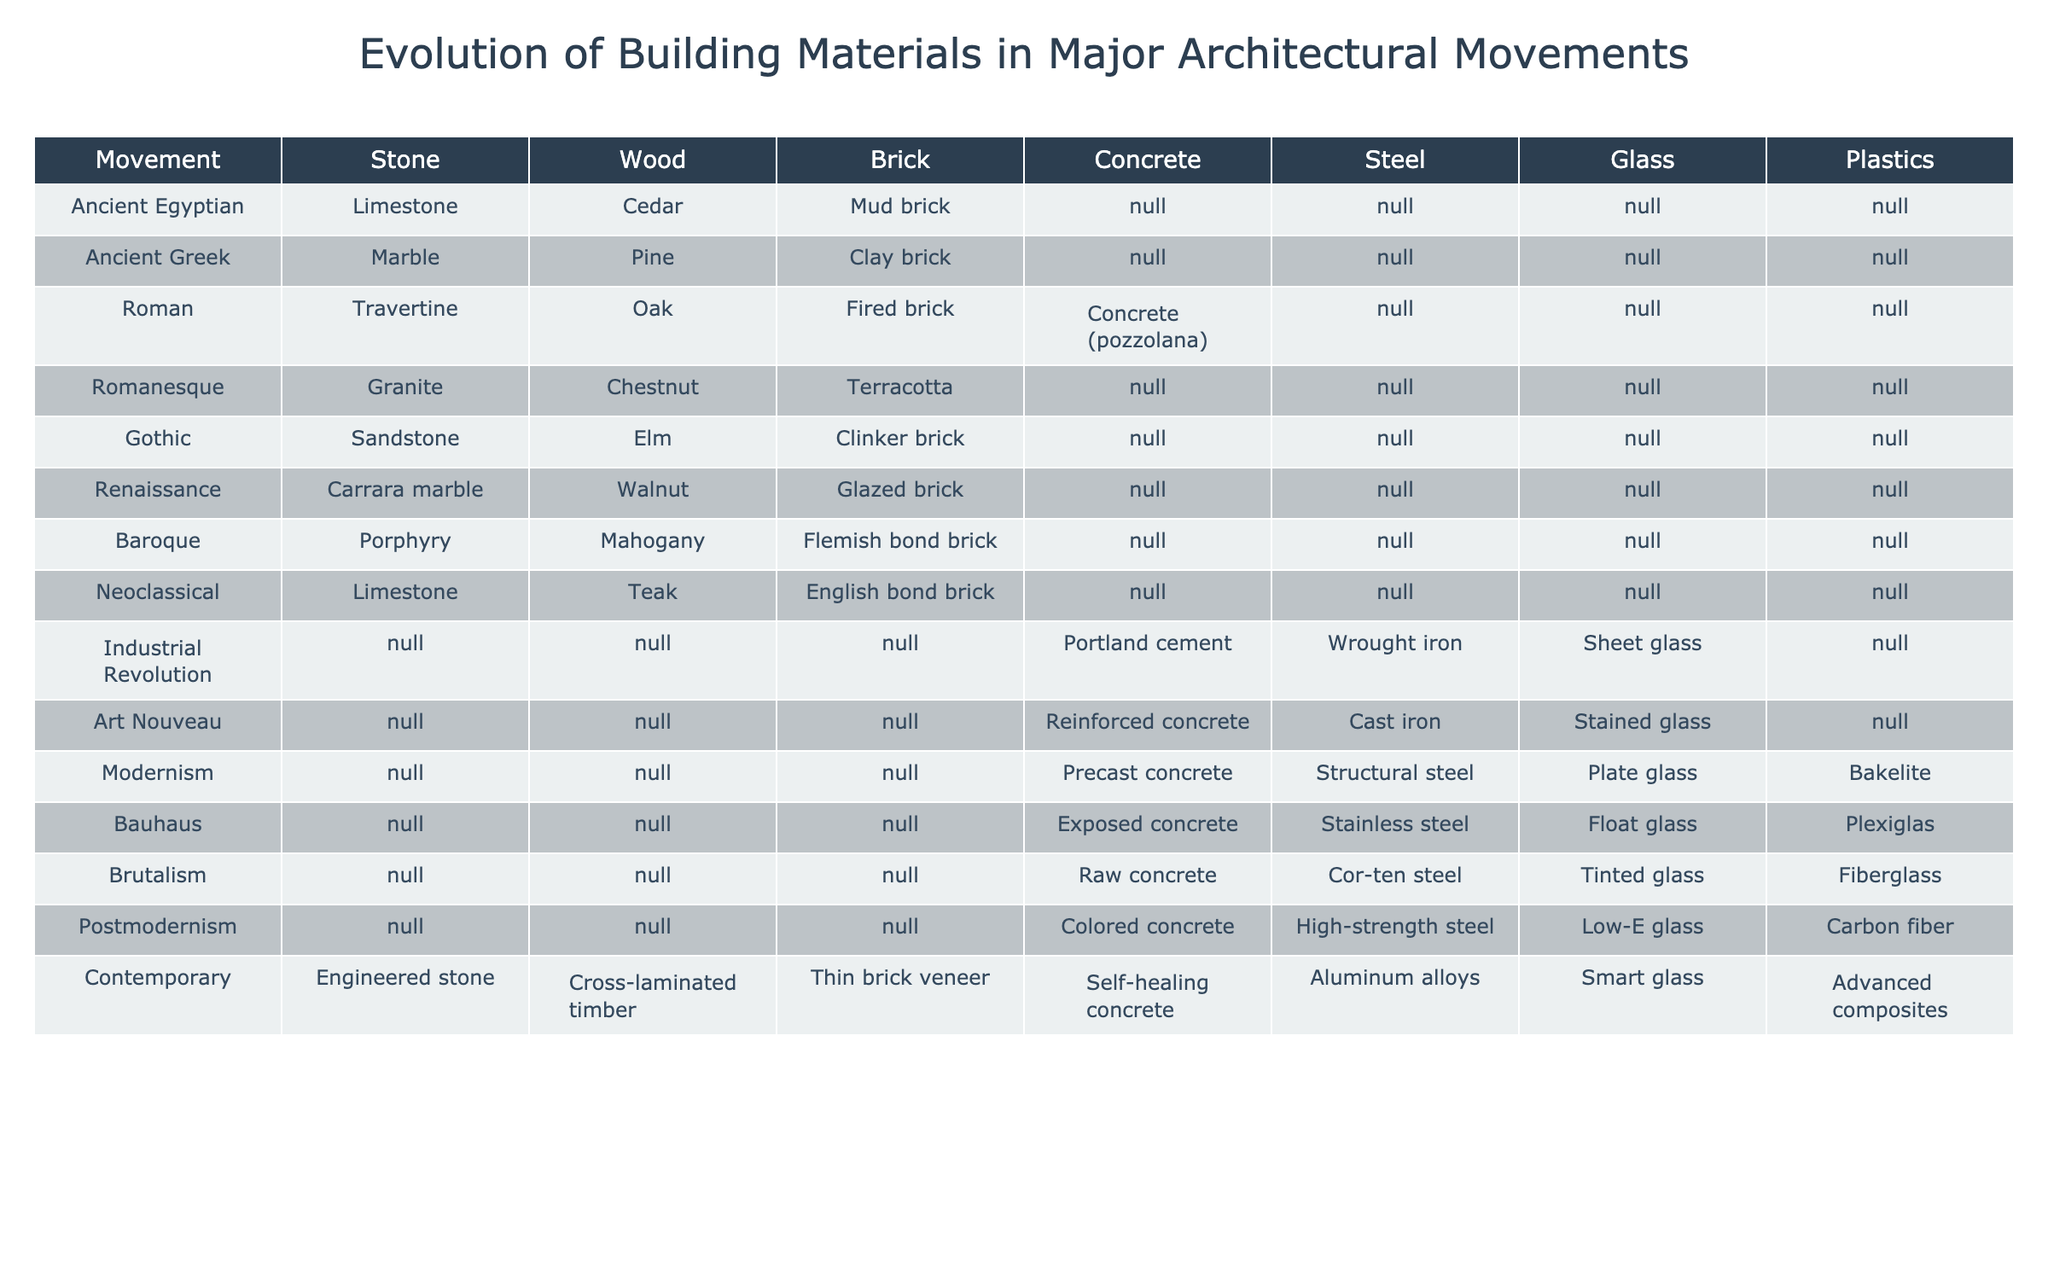What type of stone was predominantly used in the Ancient Greek architectural movement? Referring to the table, under the Ancient Greek row, the primary stone mentioned is Marble.
Answer: Marble Which architectural movement introduced Steel as a building material? Looking at the table, Steel first appears as a material in the Industrial Revolution row.
Answer: Industrial Revolution Was Wood used as a building material in the Modernism movement? The table indicates that the Modernism row does not list Wood as a building material, as it is empty in that column.
Answer: No How many different wood types were utilized in the Gothic and Renaissance architectural movements combined? The Gothic movement used Elm, while the Renaissance movement used Walnut. Both movements introduce 2 unique types of wood, and no other woods are mentioned in these rows.
Answer: 2 In which architectural movements was Brick used as a building material? Scanning the table, Brick was used in the Roman (Fired brick), Romanesque (Terracotta), Gothic (Clinker brick), Renaissance (Glazed brick), Baroque (Flemish bond brick), and Neoclassical (English bond brick) movements, totaling 6 movements.
Answer: 6 What is the difference in the use of Concrete between the Industrial Revolution and Modernism movements in terms of specific material types? The Industrial Revolution used Portland cement, while Modernism introduced Precast concrete. The difference lies in the type used (Portland cement vs. Precast concrete).
Answer: Portland cement vs. Precast concrete Did the Postmodernism movement utilize Glass as a building material? In the table, the Postmodernism row lists Low-E glass under the Glass column, which confirms that glass was indeed a material used in that movement.
Answer: Yes Which movement had the most advanced materials, including Smart glass and Advanced composites? The Contemporary movement at the bottom of the table employed both Smart glass and Advanced composites, indicating it featured the most advanced materials listed.
Answer: Contemporary In total, how many materials were used in the Bauhaus movement? Upon examining the table, the Bauhaus row shows 4 materials: Exposed concrete, Stainless steel, Float glass, and Plexiglas, making it a total of 4 materials.
Answer: 4 